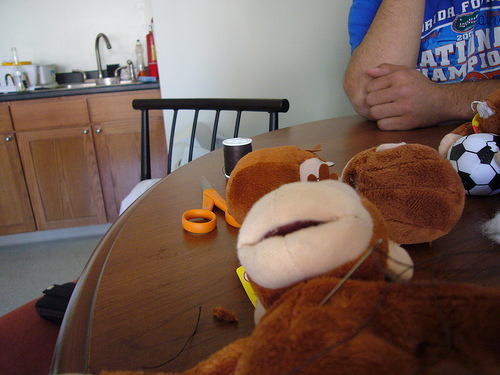<image>
Is there a scissor on the table? Yes. Looking at the image, I can see the scissor is positioned on top of the table, with the table providing support. Is the sink behind the table? Yes. From this viewpoint, the sink is positioned behind the table, with the table partially or fully occluding the sink. 